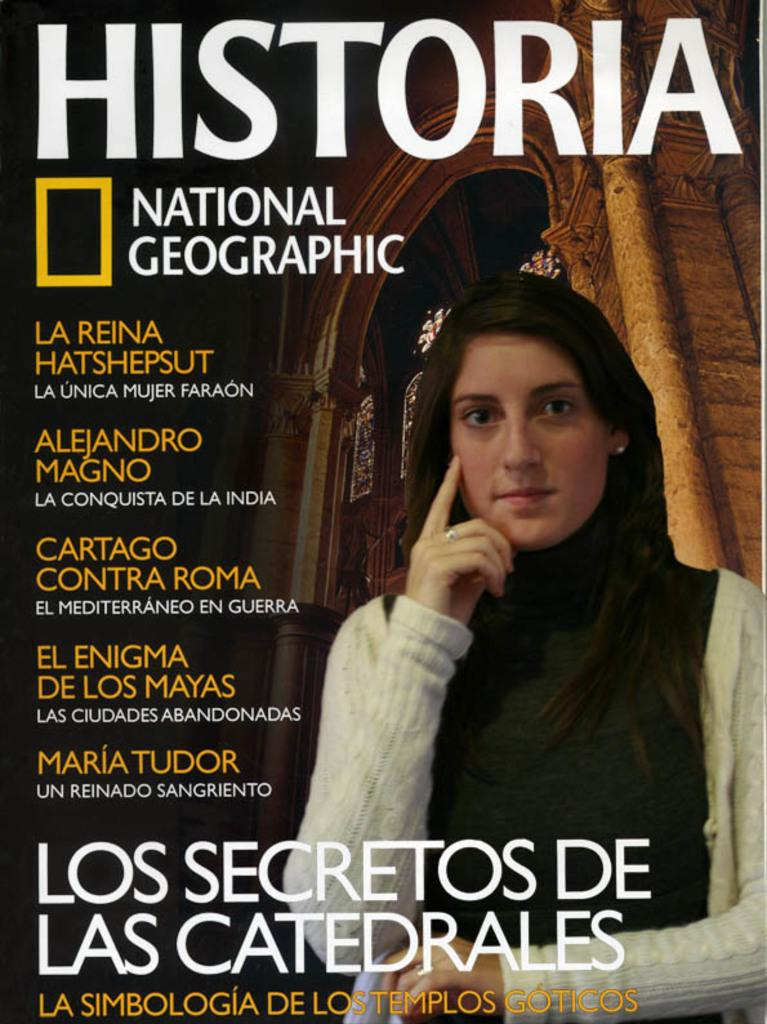What type of publication is represented by the image? The image is a cover photo of a magazine. Who is featured on the magazine cover? There is a woman depicted on the magazine cover. What design element can be seen on the magazine cover? There is an arch design construction on the magazine cover. What information is provided on the magazine cover? There is text visible on the magazine cover. What type of worm can be seen crawling on the woman's face in the image? There is no worm present on the woman's face in the image. 